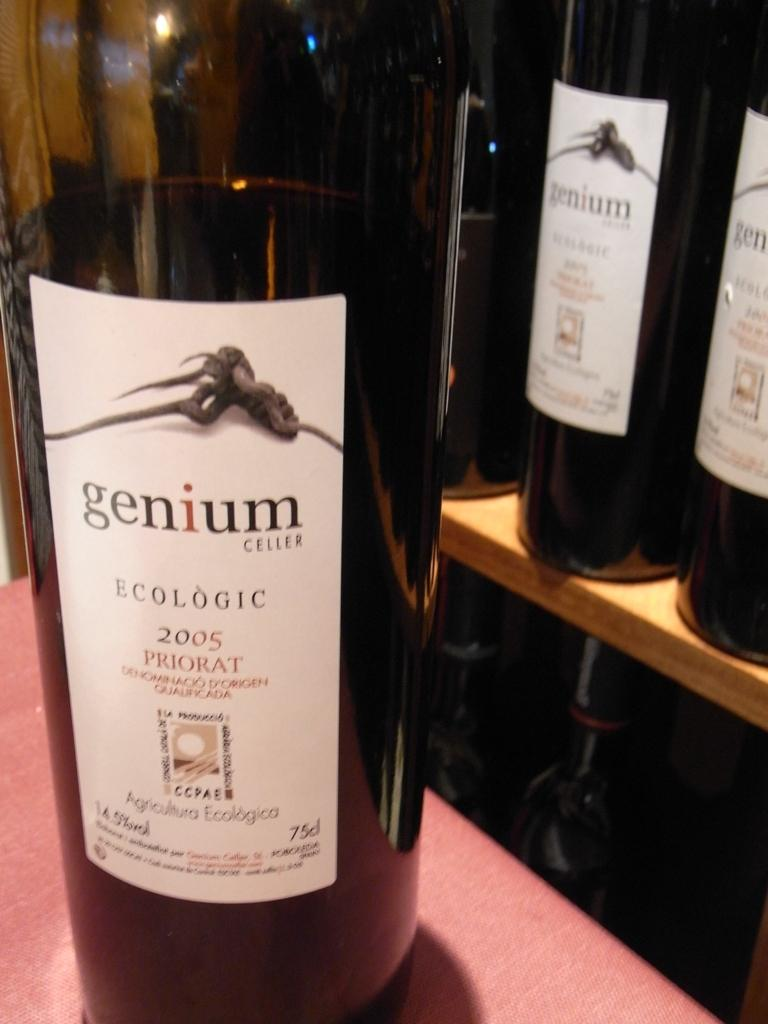<image>
Create a compact narrative representing the image presented. Bottle of alcohol with a label that says Genium on it. 